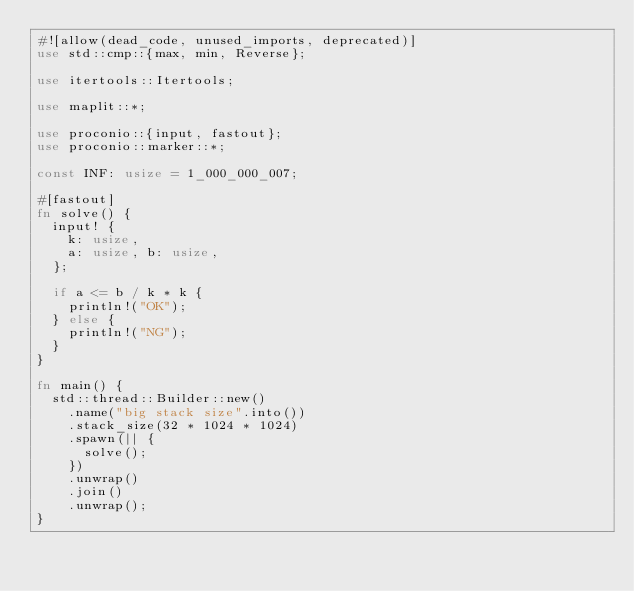<code> <loc_0><loc_0><loc_500><loc_500><_Rust_>#![allow(dead_code, unused_imports, deprecated)]
use std::cmp::{max, min, Reverse};

use itertools::Itertools;

use maplit::*;

use proconio::{input, fastout};
use proconio::marker::*;

const INF: usize = 1_000_000_007;

#[fastout]
fn solve() {
  input! {
    k: usize,
    a: usize, b: usize,
  };
  
  if a <= b / k * k {
    println!("OK");
  } else {
    println!("NG");
  }
}

fn main() {
  std::thread::Builder::new()
    .name("big stack size".into())
    .stack_size(32 * 1024 * 1024)
    .spawn(|| {
      solve();
    })
    .unwrap()
    .join()
    .unwrap();
}
</code> 